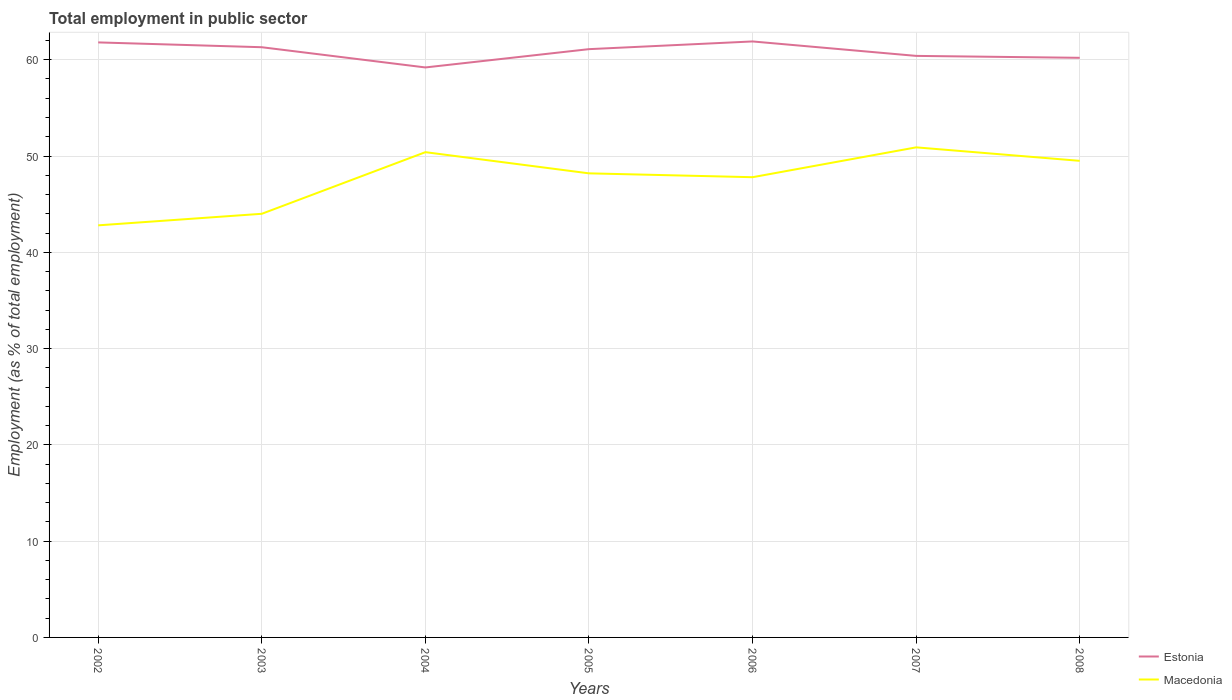How many different coloured lines are there?
Make the answer very short. 2. Does the line corresponding to Macedonia intersect with the line corresponding to Estonia?
Make the answer very short. No. Across all years, what is the maximum employment in public sector in Estonia?
Make the answer very short. 59.2. What is the total employment in public sector in Macedonia in the graph?
Provide a short and direct response. 2.2. What is the difference between the highest and the second highest employment in public sector in Estonia?
Ensure brevity in your answer.  2.7. What is the difference between the highest and the lowest employment in public sector in Estonia?
Give a very brief answer. 4. Is the employment in public sector in Macedonia strictly greater than the employment in public sector in Estonia over the years?
Give a very brief answer. Yes. How many lines are there?
Your answer should be very brief. 2. How many years are there in the graph?
Your answer should be compact. 7. Are the values on the major ticks of Y-axis written in scientific E-notation?
Provide a succinct answer. No. Does the graph contain grids?
Make the answer very short. Yes. Where does the legend appear in the graph?
Ensure brevity in your answer.  Bottom right. What is the title of the graph?
Make the answer very short. Total employment in public sector. What is the label or title of the Y-axis?
Your answer should be very brief. Employment (as % of total employment). What is the Employment (as % of total employment) in Estonia in 2002?
Keep it short and to the point. 61.8. What is the Employment (as % of total employment) of Macedonia in 2002?
Give a very brief answer. 42.8. What is the Employment (as % of total employment) in Estonia in 2003?
Make the answer very short. 61.3. What is the Employment (as % of total employment) in Estonia in 2004?
Offer a very short reply. 59.2. What is the Employment (as % of total employment) in Macedonia in 2004?
Your response must be concise. 50.4. What is the Employment (as % of total employment) in Estonia in 2005?
Give a very brief answer. 61.1. What is the Employment (as % of total employment) in Macedonia in 2005?
Your answer should be very brief. 48.2. What is the Employment (as % of total employment) of Estonia in 2006?
Provide a succinct answer. 61.9. What is the Employment (as % of total employment) in Macedonia in 2006?
Offer a terse response. 47.8. What is the Employment (as % of total employment) of Estonia in 2007?
Offer a very short reply. 60.4. What is the Employment (as % of total employment) in Macedonia in 2007?
Your answer should be compact. 50.9. What is the Employment (as % of total employment) of Estonia in 2008?
Make the answer very short. 60.2. What is the Employment (as % of total employment) in Macedonia in 2008?
Provide a succinct answer. 49.5. Across all years, what is the maximum Employment (as % of total employment) in Estonia?
Provide a short and direct response. 61.9. Across all years, what is the maximum Employment (as % of total employment) of Macedonia?
Your answer should be compact. 50.9. Across all years, what is the minimum Employment (as % of total employment) in Estonia?
Your response must be concise. 59.2. Across all years, what is the minimum Employment (as % of total employment) in Macedonia?
Give a very brief answer. 42.8. What is the total Employment (as % of total employment) of Estonia in the graph?
Offer a very short reply. 425.9. What is the total Employment (as % of total employment) of Macedonia in the graph?
Give a very brief answer. 333.6. What is the difference between the Employment (as % of total employment) of Estonia in 2002 and that in 2003?
Ensure brevity in your answer.  0.5. What is the difference between the Employment (as % of total employment) of Estonia in 2002 and that in 2005?
Your answer should be very brief. 0.7. What is the difference between the Employment (as % of total employment) in Macedonia in 2002 and that in 2005?
Offer a very short reply. -5.4. What is the difference between the Employment (as % of total employment) of Estonia in 2002 and that in 2006?
Give a very brief answer. -0.1. What is the difference between the Employment (as % of total employment) of Macedonia in 2002 and that in 2006?
Provide a short and direct response. -5. What is the difference between the Employment (as % of total employment) in Macedonia in 2002 and that in 2007?
Give a very brief answer. -8.1. What is the difference between the Employment (as % of total employment) of Estonia in 2002 and that in 2008?
Provide a short and direct response. 1.6. What is the difference between the Employment (as % of total employment) in Macedonia in 2003 and that in 2004?
Make the answer very short. -6.4. What is the difference between the Employment (as % of total employment) of Estonia in 2003 and that in 2005?
Provide a succinct answer. 0.2. What is the difference between the Employment (as % of total employment) in Estonia in 2003 and that in 2006?
Provide a short and direct response. -0.6. What is the difference between the Employment (as % of total employment) in Macedonia in 2003 and that in 2007?
Your response must be concise. -6.9. What is the difference between the Employment (as % of total employment) of Macedonia in 2003 and that in 2008?
Offer a very short reply. -5.5. What is the difference between the Employment (as % of total employment) in Macedonia in 2004 and that in 2005?
Provide a short and direct response. 2.2. What is the difference between the Employment (as % of total employment) in Estonia in 2004 and that in 2006?
Offer a very short reply. -2.7. What is the difference between the Employment (as % of total employment) in Macedonia in 2004 and that in 2006?
Offer a very short reply. 2.6. What is the difference between the Employment (as % of total employment) of Estonia in 2004 and that in 2007?
Provide a succinct answer. -1.2. What is the difference between the Employment (as % of total employment) of Macedonia in 2004 and that in 2007?
Ensure brevity in your answer.  -0.5. What is the difference between the Employment (as % of total employment) of Estonia in 2005 and that in 2007?
Make the answer very short. 0.7. What is the difference between the Employment (as % of total employment) of Macedonia in 2005 and that in 2007?
Your answer should be compact. -2.7. What is the difference between the Employment (as % of total employment) of Estonia in 2006 and that in 2007?
Offer a terse response. 1.5. What is the difference between the Employment (as % of total employment) in Macedonia in 2006 and that in 2007?
Offer a very short reply. -3.1. What is the difference between the Employment (as % of total employment) of Macedonia in 2006 and that in 2008?
Your answer should be very brief. -1.7. What is the difference between the Employment (as % of total employment) of Estonia in 2007 and that in 2008?
Your answer should be compact. 0.2. What is the difference between the Employment (as % of total employment) in Estonia in 2002 and the Employment (as % of total employment) in Macedonia in 2003?
Provide a short and direct response. 17.8. What is the difference between the Employment (as % of total employment) of Estonia in 2002 and the Employment (as % of total employment) of Macedonia in 2005?
Make the answer very short. 13.6. What is the difference between the Employment (as % of total employment) in Estonia in 2002 and the Employment (as % of total employment) in Macedonia in 2006?
Provide a succinct answer. 14. What is the difference between the Employment (as % of total employment) in Estonia in 2003 and the Employment (as % of total employment) in Macedonia in 2004?
Make the answer very short. 10.9. What is the difference between the Employment (as % of total employment) of Estonia in 2003 and the Employment (as % of total employment) of Macedonia in 2005?
Keep it short and to the point. 13.1. What is the difference between the Employment (as % of total employment) in Estonia in 2003 and the Employment (as % of total employment) in Macedonia in 2007?
Your response must be concise. 10.4. What is the difference between the Employment (as % of total employment) in Estonia in 2004 and the Employment (as % of total employment) in Macedonia in 2005?
Provide a short and direct response. 11. What is the difference between the Employment (as % of total employment) of Estonia in 2005 and the Employment (as % of total employment) of Macedonia in 2007?
Provide a short and direct response. 10.2. What is the difference between the Employment (as % of total employment) of Estonia in 2005 and the Employment (as % of total employment) of Macedonia in 2008?
Your response must be concise. 11.6. What is the difference between the Employment (as % of total employment) of Estonia in 2006 and the Employment (as % of total employment) of Macedonia in 2007?
Your answer should be very brief. 11. What is the difference between the Employment (as % of total employment) in Estonia in 2007 and the Employment (as % of total employment) in Macedonia in 2008?
Offer a terse response. 10.9. What is the average Employment (as % of total employment) of Estonia per year?
Make the answer very short. 60.84. What is the average Employment (as % of total employment) in Macedonia per year?
Your answer should be very brief. 47.66. In the year 2003, what is the difference between the Employment (as % of total employment) in Estonia and Employment (as % of total employment) in Macedonia?
Your answer should be very brief. 17.3. In the year 2006, what is the difference between the Employment (as % of total employment) in Estonia and Employment (as % of total employment) in Macedonia?
Offer a very short reply. 14.1. What is the ratio of the Employment (as % of total employment) in Estonia in 2002 to that in 2003?
Offer a very short reply. 1.01. What is the ratio of the Employment (as % of total employment) of Macedonia in 2002 to that in 2003?
Make the answer very short. 0.97. What is the ratio of the Employment (as % of total employment) of Estonia in 2002 to that in 2004?
Give a very brief answer. 1.04. What is the ratio of the Employment (as % of total employment) of Macedonia in 2002 to that in 2004?
Give a very brief answer. 0.85. What is the ratio of the Employment (as % of total employment) in Estonia in 2002 to that in 2005?
Ensure brevity in your answer.  1.01. What is the ratio of the Employment (as % of total employment) in Macedonia in 2002 to that in 2005?
Give a very brief answer. 0.89. What is the ratio of the Employment (as % of total employment) of Macedonia in 2002 to that in 2006?
Make the answer very short. 0.9. What is the ratio of the Employment (as % of total employment) in Estonia in 2002 to that in 2007?
Your response must be concise. 1.02. What is the ratio of the Employment (as % of total employment) in Macedonia in 2002 to that in 2007?
Give a very brief answer. 0.84. What is the ratio of the Employment (as % of total employment) of Estonia in 2002 to that in 2008?
Provide a succinct answer. 1.03. What is the ratio of the Employment (as % of total employment) in Macedonia in 2002 to that in 2008?
Your answer should be compact. 0.86. What is the ratio of the Employment (as % of total employment) of Estonia in 2003 to that in 2004?
Offer a very short reply. 1.04. What is the ratio of the Employment (as % of total employment) of Macedonia in 2003 to that in 2004?
Provide a succinct answer. 0.87. What is the ratio of the Employment (as % of total employment) of Estonia in 2003 to that in 2005?
Your answer should be compact. 1. What is the ratio of the Employment (as % of total employment) in Macedonia in 2003 to that in 2005?
Keep it short and to the point. 0.91. What is the ratio of the Employment (as % of total employment) of Estonia in 2003 to that in 2006?
Make the answer very short. 0.99. What is the ratio of the Employment (as % of total employment) of Macedonia in 2003 to that in 2006?
Ensure brevity in your answer.  0.92. What is the ratio of the Employment (as % of total employment) of Estonia in 2003 to that in 2007?
Offer a terse response. 1.01. What is the ratio of the Employment (as % of total employment) of Macedonia in 2003 to that in 2007?
Your response must be concise. 0.86. What is the ratio of the Employment (as % of total employment) of Estonia in 2003 to that in 2008?
Give a very brief answer. 1.02. What is the ratio of the Employment (as % of total employment) in Macedonia in 2003 to that in 2008?
Make the answer very short. 0.89. What is the ratio of the Employment (as % of total employment) in Estonia in 2004 to that in 2005?
Offer a terse response. 0.97. What is the ratio of the Employment (as % of total employment) in Macedonia in 2004 to that in 2005?
Offer a terse response. 1.05. What is the ratio of the Employment (as % of total employment) in Estonia in 2004 to that in 2006?
Offer a terse response. 0.96. What is the ratio of the Employment (as % of total employment) in Macedonia in 2004 to that in 2006?
Your answer should be very brief. 1.05. What is the ratio of the Employment (as % of total employment) of Estonia in 2004 to that in 2007?
Provide a short and direct response. 0.98. What is the ratio of the Employment (as % of total employment) in Macedonia in 2004 to that in 2007?
Give a very brief answer. 0.99. What is the ratio of the Employment (as % of total employment) in Estonia in 2004 to that in 2008?
Ensure brevity in your answer.  0.98. What is the ratio of the Employment (as % of total employment) in Macedonia in 2004 to that in 2008?
Provide a short and direct response. 1.02. What is the ratio of the Employment (as % of total employment) in Estonia in 2005 to that in 2006?
Give a very brief answer. 0.99. What is the ratio of the Employment (as % of total employment) of Macedonia in 2005 to that in 2006?
Offer a terse response. 1.01. What is the ratio of the Employment (as % of total employment) of Estonia in 2005 to that in 2007?
Your answer should be very brief. 1.01. What is the ratio of the Employment (as % of total employment) in Macedonia in 2005 to that in 2007?
Provide a short and direct response. 0.95. What is the ratio of the Employment (as % of total employment) of Macedonia in 2005 to that in 2008?
Your answer should be very brief. 0.97. What is the ratio of the Employment (as % of total employment) in Estonia in 2006 to that in 2007?
Offer a very short reply. 1.02. What is the ratio of the Employment (as % of total employment) in Macedonia in 2006 to that in 2007?
Ensure brevity in your answer.  0.94. What is the ratio of the Employment (as % of total employment) in Estonia in 2006 to that in 2008?
Your answer should be very brief. 1.03. What is the ratio of the Employment (as % of total employment) in Macedonia in 2006 to that in 2008?
Offer a very short reply. 0.97. What is the ratio of the Employment (as % of total employment) of Macedonia in 2007 to that in 2008?
Make the answer very short. 1.03. What is the difference between the highest and the second highest Employment (as % of total employment) in Estonia?
Make the answer very short. 0.1. What is the difference between the highest and the second highest Employment (as % of total employment) in Macedonia?
Your answer should be compact. 0.5. What is the difference between the highest and the lowest Employment (as % of total employment) in Macedonia?
Ensure brevity in your answer.  8.1. 